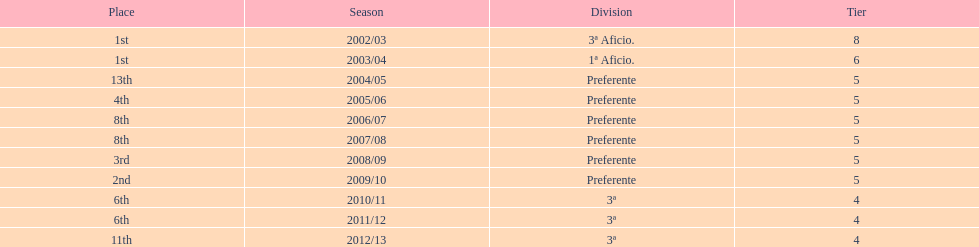In what year did the team achieve the same place as 2010/11? 2011/12. 